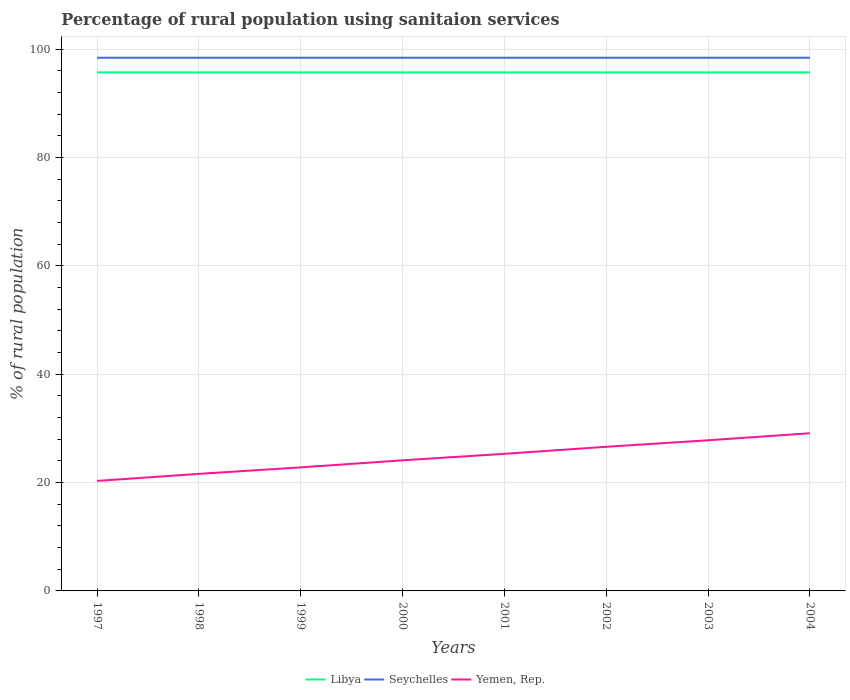Across all years, what is the maximum percentage of rural population using sanitaion services in Yemen, Rep.?
Keep it short and to the point. 20.3. What is the total percentage of rural population using sanitaion services in Seychelles in the graph?
Give a very brief answer. 0. How many years are there in the graph?
Your answer should be compact. 8. What is the difference between two consecutive major ticks on the Y-axis?
Your answer should be compact. 20. Are the values on the major ticks of Y-axis written in scientific E-notation?
Provide a short and direct response. No. Does the graph contain grids?
Offer a terse response. Yes. Where does the legend appear in the graph?
Your response must be concise. Bottom center. How many legend labels are there?
Keep it short and to the point. 3. What is the title of the graph?
Give a very brief answer. Percentage of rural population using sanitaion services. Does "Channel Islands" appear as one of the legend labels in the graph?
Provide a succinct answer. No. What is the label or title of the X-axis?
Provide a short and direct response. Years. What is the label or title of the Y-axis?
Keep it short and to the point. % of rural population. What is the % of rural population in Libya in 1997?
Your answer should be very brief. 95.7. What is the % of rural population of Seychelles in 1997?
Offer a terse response. 98.4. What is the % of rural population in Yemen, Rep. in 1997?
Make the answer very short. 20.3. What is the % of rural population in Libya in 1998?
Give a very brief answer. 95.7. What is the % of rural population in Seychelles in 1998?
Provide a succinct answer. 98.4. What is the % of rural population of Yemen, Rep. in 1998?
Provide a short and direct response. 21.6. What is the % of rural population in Libya in 1999?
Give a very brief answer. 95.7. What is the % of rural population of Seychelles in 1999?
Offer a very short reply. 98.4. What is the % of rural population in Yemen, Rep. in 1999?
Offer a very short reply. 22.8. What is the % of rural population in Libya in 2000?
Provide a short and direct response. 95.7. What is the % of rural population in Seychelles in 2000?
Offer a terse response. 98.4. What is the % of rural population in Yemen, Rep. in 2000?
Provide a short and direct response. 24.1. What is the % of rural population of Libya in 2001?
Give a very brief answer. 95.7. What is the % of rural population in Seychelles in 2001?
Make the answer very short. 98.4. What is the % of rural population in Yemen, Rep. in 2001?
Make the answer very short. 25.3. What is the % of rural population in Libya in 2002?
Give a very brief answer. 95.7. What is the % of rural population of Seychelles in 2002?
Keep it short and to the point. 98.4. What is the % of rural population of Yemen, Rep. in 2002?
Your answer should be very brief. 26.6. What is the % of rural population of Libya in 2003?
Provide a succinct answer. 95.7. What is the % of rural population in Seychelles in 2003?
Your answer should be compact. 98.4. What is the % of rural population of Yemen, Rep. in 2003?
Offer a terse response. 27.8. What is the % of rural population of Libya in 2004?
Keep it short and to the point. 95.7. What is the % of rural population in Seychelles in 2004?
Provide a short and direct response. 98.4. What is the % of rural population of Yemen, Rep. in 2004?
Offer a very short reply. 29.1. Across all years, what is the maximum % of rural population in Libya?
Your answer should be compact. 95.7. Across all years, what is the maximum % of rural population in Seychelles?
Provide a short and direct response. 98.4. Across all years, what is the maximum % of rural population of Yemen, Rep.?
Your answer should be compact. 29.1. Across all years, what is the minimum % of rural population in Libya?
Offer a terse response. 95.7. Across all years, what is the minimum % of rural population in Seychelles?
Your answer should be compact. 98.4. Across all years, what is the minimum % of rural population of Yemen, Rep.?
Your answer should be very brief. 20.3. What is the total % of rural population in Libya in the graph?
Your answer should be compact. 765.6. What is the total % of rural population of Seychelles in the graph?
Give a very brief answer. 787.2. What is the total % of rural population of Yemen, Rep. in the graph?
Your answer should be compact. 197.6. What is the difference between the % of rural population in Yemen, Rep. in 1997 and that in 1998?
Your answer should be very brief. -1.3. What is the difference between the % of rural population in Seychelles in 1997 and that in 1999?
Provide a succinct answer. 0. What is the difference between the % of rural population of Yemen, Rep. in 1997 and that in 1999?
Provide a short and direct response. -2.5. What is the difference between the % of rural population in Libya in 1997 and that in 2000?
Give a very brief answer. 0. What is the difference between the % of rural population of Seychelles in 1997 and that in 2001?
Ensure brevity in your answer.  0. What is the difference between the % of rural population of Libya in 1997 and that in 2002?
Keep it short and to the point. 0. What is the difference between the % of rural population in Seychelles in 1997 and that in 2002?
Provide a succinct answer. 0. What is the difference between the % of rural population of Yemen, Rep. in 1997 and that in 2002?
Make the answer very short. -6.3. What is the difference between the % of rural population of Libya in 1997 and that in 2003?
Your answer should be very brief. 0. What is the difference between the % of rural population in Seychelles in 1997 and that in 2003?
Your answer should be very brief. 0. What is the difference between the % of rural population in Libya in 1997 and that in 2004?
Provide a succinct answer. 0. What is the difference between the % of rural population of Seychelles in 1997 and that in 2004?
Keep it short and to the point. 0. What is the difference between the % of rural population of Yemen, Rep. in 1997 and that in 2004?
Offer a terse response. -8.8. What is the difference between the % of rural population of Libya in 1998 and that in 1999?
Keep it short and to the point. 0. What is the difference between the % of rural population of Yemen, Rep. in 1998 and that in 1999?
Your answer should be compact. -1.2. What is the difference between the % of rural population in Libya in 1998 and that in 2000?
Keep it short and to the point. 0. What is the difference between the % of rural population in Seychelles in 1998 and that in 2000?
Give a very brief answer. 0. What is the difference between the % of rural population of Yemen, Rep. in 1998 and that in 2000?
Keep it short and to the point. -2.5. What is the difference between the % of rural population of Seychelles in 1998 and that in 2002?
Offer a terse response. 0. What is the difference between the % of rural population in Yemen, Rep. in 1998 and that in 2002?
Your answer should be compact. -5. What is the difference between the % of rural population of Libya in 1998 and that in 2004?
Provide a short and direct response. 0. What is the difference between the % of rural population in Seychelles in 1998 and that in 2004?
Keep it short and to the point. 0. What is the difference between the % of rural population of Yemen, Rep. in 1998 and that in 2004?
Offer a very short reply. -7.5. What is the difference between the % of rural population of Seychelles in 1999 and that in 2000?
Offer a very short reply. 0. What is the difference between the % of rural population of Yemen, Rep. in 1999 and that in 2000?
Make the answer very short. -1.3. What is the difference between the % of rural population of Seychelles in 1999 and that in 2002?
Your answer should be very brief. 0. What is the difference between the % of rural population in Yemen, Rep. in 1999 and that in 2002?
Ensure brevity in your answer.  -3.8. What is the difference between the % of rural population of Libya in 1999 and that in 2003?
Make the answer very short. 0. What is the difference between the % of rural population of Libya in 1999 and that in 2004?
Your response must be concise. 0. What is the difference between the % of rural population in Seychelles in 2000 and that in 2002?
Your response must be concise. 0. What is the difference between the % of rural population of Seychelles in 2000 and that in 2003?
Your answer should be compact. 0. What is the difference between the % of rural population in Yemen, Rep. in 2000 and that in 2003?
Your answer should be very brief. -3.7. What is the difference between the % of rural population in Libya in 2000 and that in 2004?
Keep it short and to the point. 0. What is the difference between the % of rural population of Seychelles in 2000 and that in 2004?
Provide a succinct answer. 0. What is the difference between the % of rural population in Yemen, Rep. in 2000 and that in 2004?
Give a very brief answer. -5. What is the difference between the % of rural population of Libya in 2001 and that in 2002?
Offer a very short reply. 0. What is the difference between the % of rural population in Yemen, Rep. in 2001 and that in 2003?
Keep it short and to the point. -2.5. What is the difference between the % of rural population of Seychelles in 2001 and that in 2004?
Offer a terse response. 0. What is the difference between the % of rural population of Yemen, Rep. in 2001 and that in 2004?
Offer a very short reply. -3.8. What is the difference between the % of rural population of Libya in 2002 and that in 2003?
Keep it short and to the point. 0. What is the difference between the % of rural population of Seychelles in 2002 and that in 2003?
Provide a short and direct response. 0. What is the difference between the % of rural population of Libya in 2002 and that in 2004?
Ensure brevity in your answer.  0. What is the difference between the % of rural population of Seychelles in 2002 and that in 2004?
Ensure brevity in your answer.  0. What is the difference between the % of rural population in Yemen, Rep. in 2002 and that in 2004?
Give a very brief answer. -2.5. What is the difference between the % of rural population of Seychelles in 2003 and that in 2004?
Keep it short and to the point. 0. What is the difference between the % of rural population in Yemen, Rep. in 2003 and that in 2004?
Your response must be concise. -1.3. What is the difference between the % of rural population in Libya in 1997 and the % of rural population in Yemen, Rep. in 1998?
Your answer should be compact. 74.1. What is the difference between the % of rural population of Seychelles in 1997 and the % of rural population of Yemen, Rep. in 1998?
Ensure brevity in your answer.  76.8. What is the difference between the % of rural population of Libya in 1997 and the % of rural population of Yemen, Rep. in 1999?
Provide a succinct answer. 72.9. What is the difference between the % of rural population in Seychelles in 1997 and the % of rural population in Yemen, Rep. in 1999?
Make the answer very short. 75.6. What is the difference between the % of rural population in Libya in 1997 and the % of rural population in Yemen, Rep. in 2000?
Your answer should be compact. 71.6. What is the difference between the % of rural population in Seychelles in 1997 and the % of rural population in Yemen, Rep. in 2000?
Your response must be concise. 74.3. What is the difference between the % of rural population in Libya in 1997 and the % of rural population in Seychelles in 2001?
Keep it short and to the point. -2.7. What is the difference between the % of rural population of Libya in 1997 and the % of rural population of Yemen, Rep. in 2001?
Your response must be concise. 70.4. What is the difference between the % of rural population of Seychelles in 1997 and the % of rural population of Yemen, Rep. in 2001?
Give a very brief answer. 73.1. What is the difference between the % of rural population in Libya in 1997 and the % of rural population in Seychelles in 2002?
Provide a succinct answer. -2.7. What is the difference between the % of rural population of Libya in 1997 and the % of rural population of Yemen, Rep. in 2002?
Ensure brevity in your answer.  69.1. What is the difference between the % of rural population of Seychelles in 1997 and the % of rural population of Yemen, Rep. in 2002?
Your answer should be very brief. 71.8. What is the difference between the % of rural population in Libya in 1997 and the % of rural population in Yemen, Rep. in 2003?
Make the answer very short. 67.9. What is the difference between the % of rural population in Seychelles in 1997 and the % of rural population in Yemen, Rep. in 2003?
Your answer should be compact. 70.6. What is the difference between the % of rural population of Libya in 1997 and the % of rural population of Seychelles in 2004?
Your response must be concise. -2.7. What is the difference between the % of rural population of Libya in 1997 and the % of rural population of Yemen, Rep. in 2004?
Your answer should be compact. 66.6. What is the difference between the % of rural population in Seychelles in 1997 and the % of rural population in Yemen, Rep. in 2004?
Your answer should be compact. 69.3. What is the difference between the % of rural population in Libya in 1998 and the % of rural population in Seychelles in 1999?
Make the answer very short. -2.7. What is the difference between the % of rural population in Libya in 1998 and the % of rural population in Yemen, Rep. in 1999?
Your response must be concise. 72.9. What is the difference between the % of rural population in Seychelles in 1998 and the % of rural population in Yemen, Rep. in 1999?
Offer a very short reply. 75.6. What is the difference between the % of rural population in Libya in 1998 and the % of rural population in Yemen, Rep. in 2000?
Make the answer very short. 71.6. What is the difference between the % of rural population of Seychelles in 1998 and the % of rural population of Yemen, Rep. in 2000?
Offer a terse response. 74.3. What is the difference between the % of rural population in Libya in 1998 and the % of rural population in Seychelles in 2001?
Offer a terse response. -2.7. What is the difference between the % of rural population of Libya in 1998 and the % of rural population of Yemen, Rep. in 2001?
Give a very brief answer. 70.4. What is the difference between the % of rural population of Seychelles in 1998 and the % of rural population of Yemen, Rep. in 2001?
Offer a terse response. 73.1. What is the difference between the % of rural population of Libya in 1998 and the % of rural population of Yemen, Rep. in 2002?
Make the answer very short. 69.1. What is the difference between the % of rural population in Seychelles in 1998 and the % of rural population in Yemen, Rep. in 2002?
Provide a succinct answer. 71.8. What is the difference between the % of rural population of Libya in 1998 and the % of rural population of Seychelles in 2003?
Offer a very short reply. -2.7. What is the difference between the % of rural population in Libya in 1998 and the % of rural population in Yemen, Rep. in 2003?
Offer a very short reply. 67.9. What is the difference between the % of rural population in Seychelles in 1998 and the % of rural population in Yemen, Rep. in 2003?
Offer a terse response. 70.6. What is the difference between the % of rural population of Libya in 1998 and the % of rural population of Seychelles in 2004?
Your answer should be compact. -2.7. What is the difference between the % of rural population in Libya in 1998 and the % of rural population in Yemen, Rep. in 2004?
Keep it short and to the point. 66.6. What is the difference between the % of rural population of Seychelles in 1998 and the % of rural population of Yemen, Rep. in 2004?
Offer a very short reply. 69.3. What is the difference between the % of rural population in Libya in 1999 and the % of rural population in Yemen, Rep. in 2000?
Give a very brief answer. 71.6. What is the difference between the % of rural population of Seychelles in 1999 and the % of rural population of Yemen, Rep. in 2000?
Ensure brevity in your answer.  74.3. What is the difference between the % of rural population in Libya in 1999 and the % of rural population in Yemen, Rep. in 2001?
Offer a terse response. 70.4. What is the difference between the % of rural population of Seychelles in 1999 and the % of rural population of Yemen, Rep. in 2001?
Your answer should be very brief. 73.1. What is the difference between the % of rural population of Libya in 1999 and the % of rural population of Seychelles in 2002?
Ensure brevity in your answer.  -2.7. What is the difference between the % of rural population in Libya in 1999 and the % of rural population in Yemen, Rep. in 2002?
Offer a very short reply. 69.1. What is the difference between the % of rural population in Seychelles in 1999 and the % of rural population in Yemen, Rep. in 2002?
Give a very brief answer. 71.8. What is the difference between the % of rural population in Libya in 1999 and the % of rural population in Yemen, Rep. in 2003?
Your answer should be very brief. 67.9. What is the difference between the % of rural population in Seychelles in 1999 and the % of rural population in Yemen, Rep. in 2003?
Ensure brevity in your answer.  70.6. What is the difference between the % of rural population of Libya in 1999 and the % of rural population of Seychelles in 2004?
Your answer should be very brief. -2.7. What is the difference between the % of rural population of Libya in 1999 and the % of rural population of Yemen, Rep. in 2004?
Your answer should be very brief. 66.6. What is the difference between the % of rural population in Seychelles in 1999 and the % of rural population in Yemen, Rep. in 2004?
Provide a succinct answer. 69.3. What is the difference between the % of rural population in Libya in 2000 and the % of rural population in Seychelles in 2001?
Ensure brevity in your answer.  -2.7. What is the difference between the % of rural population in Libya in 2000 and the % of rural population in Yemen, Rep. in 2001?
Make the answer very short. 70.4. What is the difference between the % of rural population in Seychelles in 2000 and the % of rural population in Yemen, Rep. in 2001?
Your response must be concise. 73.1. What is the difference between the % of rural population of Libya in 2000 and the % of rural population of Yemen, Rep. in 2002?
Your answer should be compact. 69.1. What is the difference between the % of rural population in Seychelles in 2000 and the % of rural population in Yemen, Rep. in 2002?
Offer a terse response. 71.8. What is the difference between the % of rural population of Libya in 2000 and the % of rural population of Yemen, Rep. in 2003?
Your answer should be very brief. 67.9. What is the difference between the % of rural population in Seychelles in 2000 and the % of rural population in Yemen, Rep. in 2003?
Your response must be concise. 70.6. What is the difference between the % of rural population in Libya in 2000 and the % of rural population in Seychelles in 2004?
Give a very brief answer. -2.7. What is the difference between the % of rural population in Libya in 2000 and the % of rural population in Yemen, Rep. in 2004?
Provide a succinct answer. 66.6. What is the difference between the % of rural population of Seychelles in 2000 and the % of rural population of Yemen, Rep. in 2004?
Your answer should be compact. 69.3. What is the difference between the % of rural population in Libya in 2001 and the % of rural population in Seychelles in 2002?
Your response must be concise. -2.7. What is the difference between the % of rural population in Libya in 2001 and the % of rural population in Yemen, Rep. in 2002?
Provide a succinct answer. 69.1. What is the difference between the % of rural population in Seychelles in 2001 and the % of rural population in Yemen, Rep. in 2002?
Provide a succinct answer. 71.8. What is the difference between the % of rural population in Libya in 2001 and the % of rural population in Seychelles in 2003?
Provide a succinct answer. -2.7. What is the difference between the % of rural population of Libya in 2001 and the % of rural population of Yemen, Rep. in 2003?
Your answer should be compact. 67.9. What is the difference between the % of rural population in Seychelles in 2001 and the % of rural population in Yemen, Rep. in 2003?
Make the answer very short. 70.6. What is the difference between the % of rural population in Libya in 2001 and the % of rural population in Seychelles in 2004?
Offer a very short reply. -2.7. What is the difference between the % of rural population of Libya in 2001 and the % of rural population of Yemen, Rep. in 2004?
Make the answer very short. 66.6. What is the difference between the % of rural population in Seychelles in 2001 and the % of rural population in Yemen, Rep. in 2004?
Offer a very short reply. 69.3. What is the difference between the % of rural population of Libya in 2002 and the % of rural population of Seychelles in 2003?
Provide a short and direct response. -2.7. What is the difference between the % of rural population in Libya in 2002 and the % of rural population in Yemen, Rep. in 2003?
Your answer should be very brief. 67.9. What is the difference between the % of rural population of Seychelles in 2002 and the % of rural population of Yemen, Rep. in 2003?
Offer a very short reply. 70.6. What is the difference between the % of rural population of Libya in 2002 and the % of rural population of Yemen, Rep. in 2004?
Make the answer very short. 66.6. What is the difference between the % of rural population in Seychelles in 2002 and the % of rural population in Yemen, Rep. in 2004?
Provide a short and direct response. 69.3. What is the difference between the % of rural population of Libya in 2003 and the % of rural population of Yemen, Rep. in 2004?
Your answer should be compact. 66.6. What is the difference between the % of rural population in Seychelles in 2003 and the % of rural population in Yemen, Rep. in 2004?
Offer a very short reply. 69.3. What is the average % of rural population of Libya per year?
Give a very brief answer. 95.7. What is the average % of rural population in Seychelles per year?
Make the answer very short. 98.4. What is the average % of rural population of Yemen, Rep. per year?
Your response must be concise. 24.7. In the year 1997, what is the difference between the % of rural population in Libya and % of rural population in Yemen, Rep.?
Ensure brevity in your answer.  75.4. In the year 1997, what is the difference between the % of rural population in Seychelles and % of rural population in Yemen, Rep.?
Provide a succinct answer. 78.1. In the year 1998, what is the difference between the % of rural population in Libya and % of rural population in Seychelles?
Your response must be concise. -2.7. In the year 1998, what is the difference between the % of rural population of Libya and % of rural population of Yemen, Rep.?
Your answer should be compact. 74.1. In the year 1998, what is the difference between the % of rural population in Seychelles and % of rural population in Yemen, Rep.?
Provide a short and direct response. 76.8. In the year 1999, what is the difference between the % of rural population in Libya and % of rural population in Yemen, Rep.?
Provide a succinct answer. 72.9. In the year 1999, what is the difference between the % of rural population in Seychelles and % of rural population in Yemen, Rep.?
Ensure brevity in your answer.  75.6. In the year 2000, what is the difference between the % of rural population in Libya and % of rural population in Yemen, Rep.?
Provide a short and direct response. 71.6. In the year 2000, what is the difference between the % of rural population of Seychelles and % of rural population of Yemen, Rep.?
Your answer should be very brief. 74.3. In the year 2001, what is the difference between the % of rural population in Libya and % of rural population in Yemen, Rep.?
Your response must be concise. 70.4. In the year 2001, what is the difference between the % of rural population of Seychelles and % of rural population of Yemen, Rep.?
Offer a very short reply. 73.1. In the year 2002, what is the difference between the % of rural population of Libya and % of rural population of Seychelles?
Your answer should be compact. -2.7. In the year 2002, what is the difference between the % of rural population of Libya and % of rural population of Yemen, Rep.?
Provide a succinct answer. 69.1. In the year 2002, what is the difference between the % of rural population in Seychelles and % of rural population in Yemen, Rep.?
Make the answer very short. 71.8. In the year 2003, what is the difference between the % of rural population in Libya and % of rural population in Seychelles?
Your answer should be compact. -2.7. In the year 2003, what is the difference between the % of rural population of Libya and % of rural population of Yemen, Rep.?
Offer a terse response. 67.9. In the year 2003, what is the difference between the % of rural population of Seychelles and % of rural population of Yemen, Rep.?
Keep it short and to the point. 70.6. In the year 2004, what is the difference between the % of rural population in Libya and % of rural population in Seychelles?
Provide a succinct answer. -2.7. In the year 2004, what is the difference between the % of rural population in Libya and % of rural population in Yemen, Rep.?
Give a very brief answer. 66.6. In the year 2004, what is the difference between the % of rural population in Seychelles and % of rural population in Yemen, Rep.?
Your answer should be very brief. 69.3. What is the ratio of the % of rural population in Seychelles in 1997 to that in 1998?
Provide a succinct answer. 1. What is the ratio of the % of rural population of Yemen, Rep. in 1997 to that in 1998?
Make the answer very short. 0.94. What is the ratio of the % of rural population in Libya in 1997 to that in 1999?
Offer a very short reply. 1. What is the ratio of the % of rural population in Yemen, Rep. in 1997 to that in 1999?
Your answer should be compact. 0.89. What is the ratio of the % of rural population in Libya in 1997 to that in 2000?
Your answer should be very brief. 1. What is the ratio of the % of rural population in Yemen, Rep. in 1997 to that in 2000?
Your response must be concise. 0.84. What is the ratio of the % of rural population of Libya in 1997 to that in 2001?
Your answer should be compact. 1. What is the ratio of the % of rural population in Yemen, Rep. in 1997 to that in 2001?
Give a very brief answer. 0.8. What is the ratio of the % of rural population in Seychelles in 1997 to that in 2002?
Make the answer very short. 1. What is the ratio of the % of rural population in Yemen, Rep. in 1997 to that in 2002?
Your response must be concise. 0.76. What is the ratio of the % of rural population of Yemen, Rep. in 1997 to that in 2003?
Offer a very short reply. 0.73. What is the ratio of the % of rural population of Libya in 1997 to that in 2004?
Give a very brief answer. 1. What is the ratio of the % of rural population in Seychelles in 1997 to that in 2004?
Ensure brevity in your answer.  1. What is the ratio of the % of rural population of Yemen, Rep. in 1997 to that in 2004?
Keep it short and to the point. 0.7. What is the ratio of the % of rural population of Libya in 1998 to that in 2000?
Give a very brief answer. 1. What is the ratio of the % of rural population in Seychelles in 1998 to that in 2000?
Provide a succinct answer. 1. What is the ratio of the % of rural population of Yemen, Rep. in 1998 to that in 2000?
Ensure brevity in your answer.  0.9. What is the ratio of the % of rural population of Seychelles in 1998 to that in 2001?
Provide a succinct answer. 1. What is the ratio of the % of rural population in Yemen, Rep. in 1998 to that in 2001?
Your response must be concise. 0.85. What is the ratio of the % of rural population of Libya in 1998 to that in 2002?
Your answer should be compact. 1. What is the ratio of the % of rural population of Seychelles in 1998 to that in 2002?
Offer a very short reply. 1. What is the ratio of the % of rural population in Yemen, Rep. in 1998 to that in 2002?
Keep it short and to the point. 0.81. What is the ratio of the % of rural population of Libya in 1998 to that in 2003?
Ensure brevity in your answer.  1. What is the ratio of the % of rural population of Seychelles in 1998 to that in 2003?
Make the answer very short. 1. What is the ratio of the % of rural population in Yemen, Rep. in 1998 to that in 2003?
Provide a succinct answer. 0.78. What is the ratio of the % of rural population in Libya in 1998 to that in 2004?
Your response must be concise. 1. What is the ratio of the % of rural population of Seychelles in 1998 to that in 2004?
Provide a short and direct response. 1. What is the ratio of the % of rural population in Yemen, Rep. in 1998 to that in 2004?
Keep it short and to the point. 0.74. What is the ratio of the % of rural population of Seychelles in 1999 to that in 2000?
Provide a succinct answer. 1. What is the ratio of the % of rural population in Yemen, Rep. in 1999 to that in 2000?
Offer a very short reply. 0.95. What is the ratio of the % of rural population in Yemen, Rep. in 1999 to that in 2001?
Give a very brief answer. 0.9. What is the ratio of the % of rural population of Libya in 1999 to that in 2003?
Your response must be concise. 1. What is the ratio of the % of rural population of Seychelles in 1999 to that in 2003?
Offer a terse response. 1. What is the ratio of the % of rural population in Yemen, Rep. in 1999 to that in 2003?
Your response must be concise. 0.82. What is the ratio of the % of rural population of Libya in 1999 to that in 2004?
Your answer should be very brief. 1. What is the ratio of the % of rural population in Yemen, Rep. in 1999 to that in 2004?
Keep it short and to the point. 0.78. What is the ratio of the % of rural population in Libya in 2000 to that in 2001?
Ensure brevity in your answer.  1. What is the ratio of the % of rural population of Yemen, Rep. in 2000 to that in 2001?
Provide a short and direct response. 0.95. What is the ratio of the % of rural population in Yemen, Rep. in 2000 to that in 2002?
Offer a very short reply. 0.91. What is the ratio of the % of rural population of Yemen, Rep. in 2000 to that in 2003?
Your answer should be compact. 0.87. What is the ratio of the % of rural population in Seychelles in 2000 to that in 2004?
Make the answer very short. 1. What is the ratio of the % of rural population of Yemen, Rep. in 2000 to that in 2004?
Offer a very short reply. 0.83. What is the ratio of the % of rural population in Libya in 2001 to that in 2002?
Offer a very short reply. 1. What is the ratio of the % of rural population in Seychelles in 2001 to that in 2002?
Your response must be concise. 1. What is the ratio of the % of rural population of Yemen, Rep. in 2001 to that in 2002?
Provide a succinct answer. 0.95. What is the ratio of the % of rural population in Libya in 2001 to that in 2003?
Give a very brief answer. 1. What is the ratio of the % of rural population in Seychelles in 2001 to that in 2003?
Your response must be concise. 1. What is the ratio of the % of rural population in Yemen, Rep. in 2001 to that in 2003?
Provide a succinct answer. 0.91. What is the ratio of the % of rural population of Seychelles in 2001 to that in 2004?
Your answer should be compact. 1. What is the ratio of the % of rural population of Yemen, Rep. in 2001 to that in 2004?
Make the answer very short. 0.87. What is the ratio of the % of rural population of Seychelles in 2002 to that in 2003?
Make the answer very short. 1. What is the ratio of the % of rural population of Yemen, Rep. in 2002 to that in 2003?
Your answer should be very brief. 0.96. What is the ratio of the % of rural population in Libya in 2002 to that in 2004?
Make the answer very short. 1. What is the ratio of the % of rural population of Yemen, Rep. in 2002 to that in 2004?
Make the answer very short. 0.91. What is the ratio of the % of rural population of Seychelles in 2003 to that in 2004?
Your answer should be compact. 1. What is the ratio of the % of rural population of Yemen, Rep. in 2003 to that in 2004?
Ensure brevity in your answer.  0.96. What is the difference between the highest and the second highest % of rural population in Libya?
Provide a succinct answer. 0. What is the difference between the highest and the lowest % of rural population in Libya?
Ensure brevity in your answer.  0. What is the difference between the highest and the lowest % of rural population in Seychelles?
Provide a succinct answer. 0. What is the difference between the highest and the lowest % of rural population of Yemen, Rep.?
Ensure brevity in your answer.  8.8. 